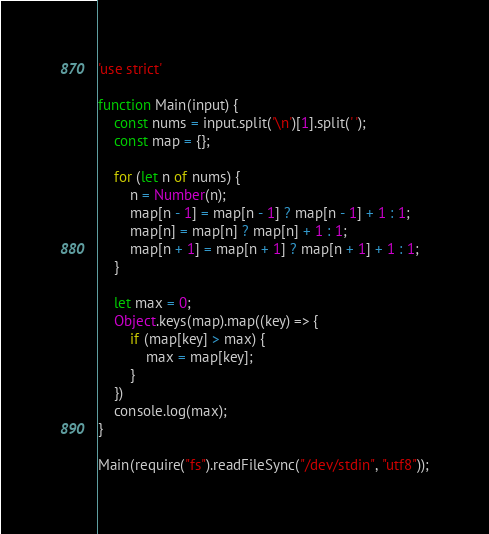Convert code to text. <code><loc_0><loc_0><loc_500><loc_500><_JavaScript_>'use strict'

function Main(input) {
    const nums = input.split('\n')[1].split(' ');
    const map = {};

    for (let n of nums) {
        n = Number(n);
        map[n - 1] = map[n - 1] ? map[n - 1] + 1 : 1;
        map[n] = map[n] ? map[n] + 1 : 1;
        map[n + 1] = map[n + 1] ? map[n + 1] + 1 : 1;
    }
    
    let max = 0;
    Object.keys(map).map((key) => {
        if (map[key] > max) {
            max = map[key];
        }
    })
    console.log(max);
}

Main(require("fs").readFileSync("/dev/stdin", "utf8"));
</code> 